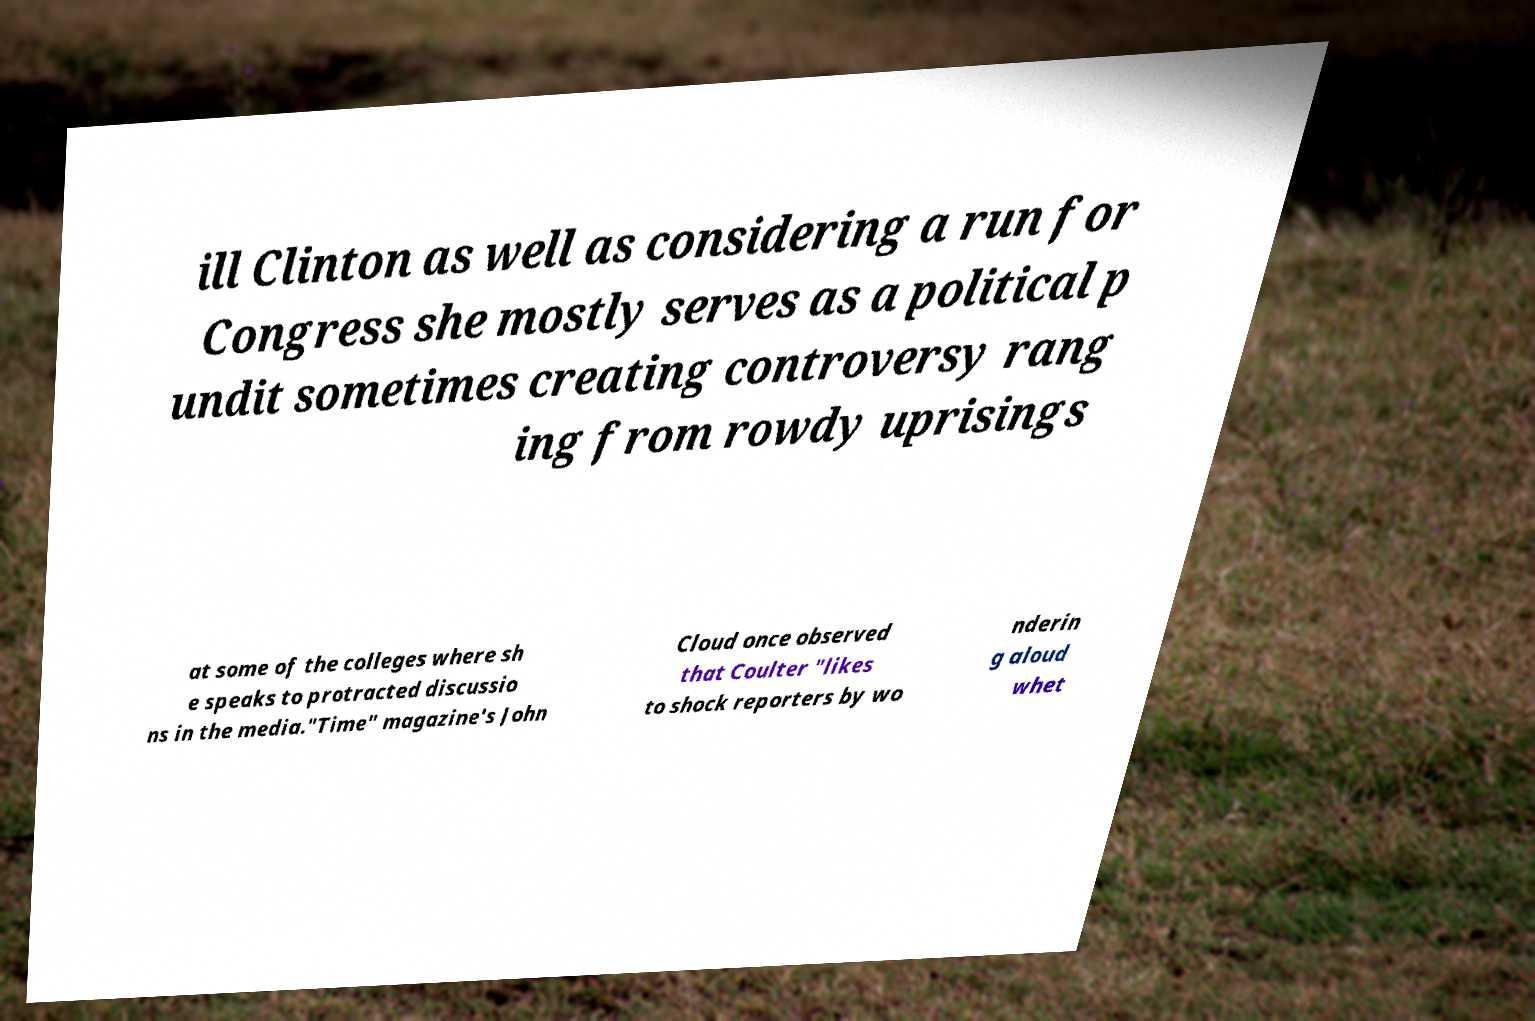Please identify and transcribe the text found in this image. ill Clinton as well as considering a run for Congress she mostly serves as a political p undit sometimes creating controversy rang ing from rowdy uprisings at some of the colleges where sh e speaks to protracted discussio ns in the media."Time" magazine's John Cloud once observed that Coulter "likes to shock reporters by wo nderin g aloud whet 